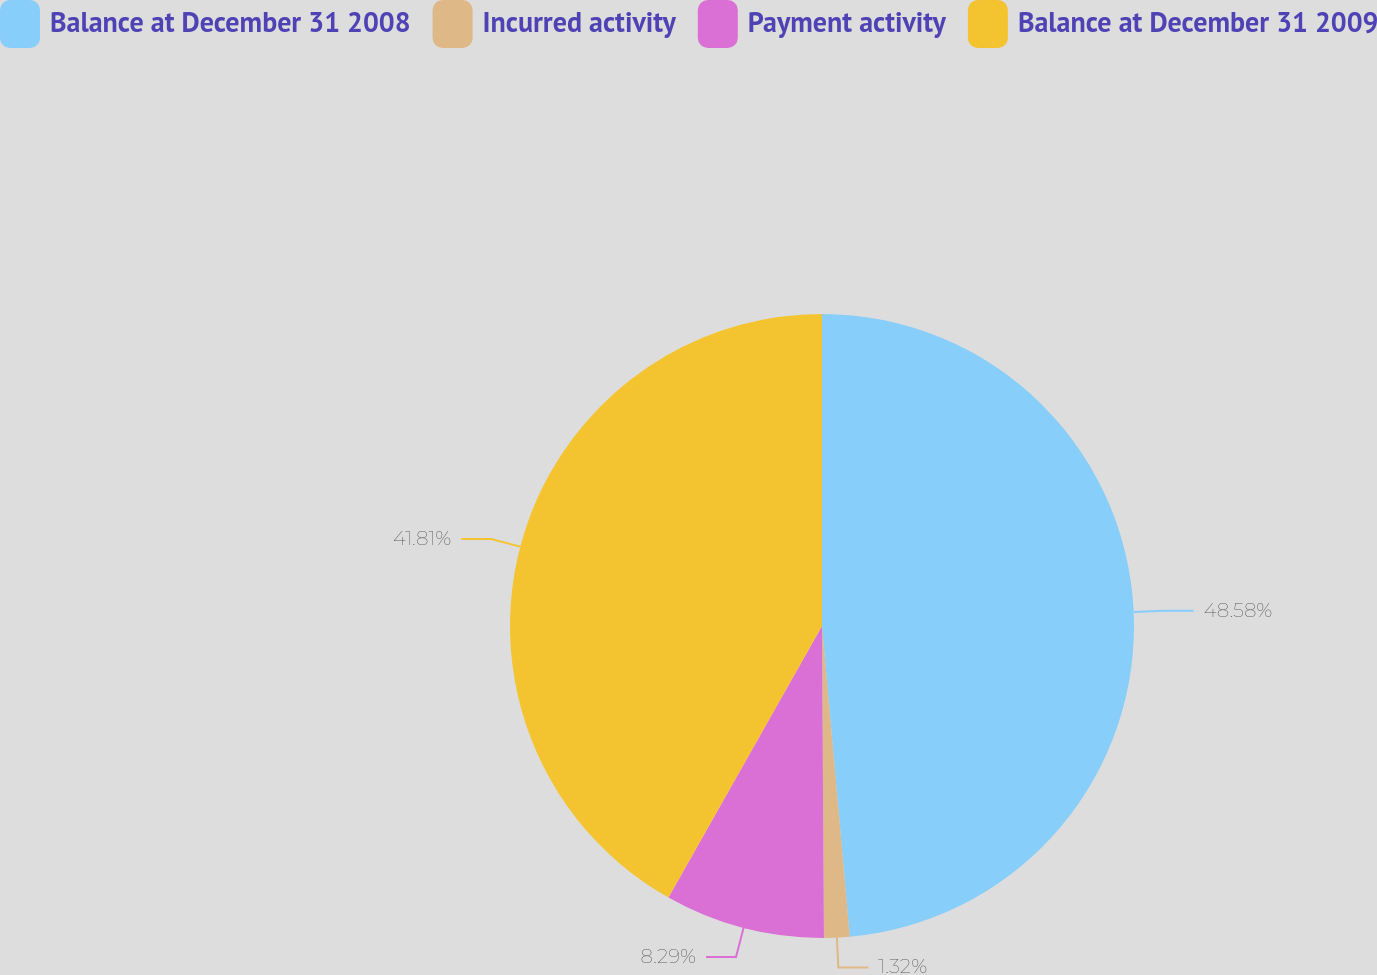Convert chart. <chart><loc_0><loc_0><loc_500><loc_500><pie_chart><fcel>Balance at December 31 2008<fcel>Incurred activity<fcel>Payment activity<fcel>Balance at December 31 2009<nl><fcel>48.58%<fcel>1.32%<fcel>8.29%<fcel>41.81%<nl></chart> 